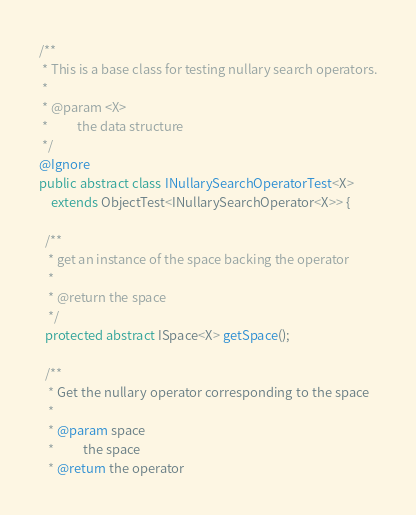<code> <loc_0><loc_0><loc_500><loc_500><_Java_>/**
 * This is a base class for testing nullary search operators.
 *
 * @param <X>
 *          the data structure
 */
@Ignore
public abstract class INullarySearchOperatorTest<X>
    extends ObjectTest<INullarySearchOperator<X>> {

  /**
   * get an instance of the space backing the operator
   *
   * @return the space
   */
  protected abstract ISpace<X> getSpace();

  /**
   * Get the nullary operator corresponding to the space
   *
   * @param space
   *          the space
   * @return the operator</code> 